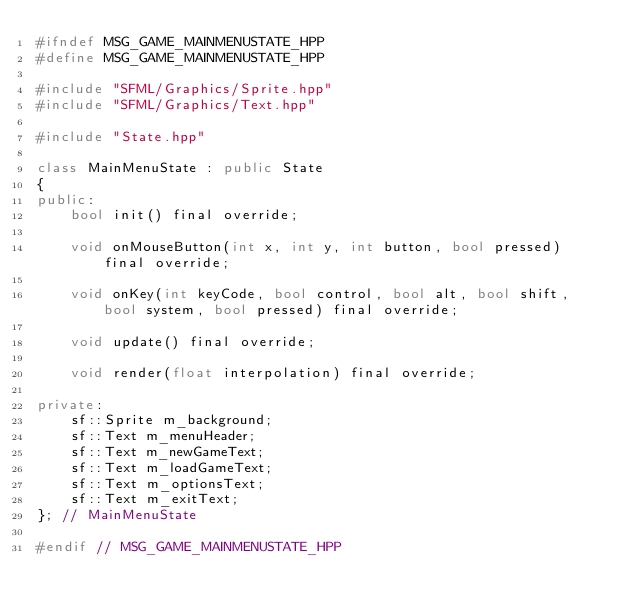Convert code to text. <code><loc_0><loc_0><loc_500><loc_500><_C++_>#ifndef MSG_GAME_MAINMENUSTATE_HPP
#define MSG_GAME_MAINMENUSTATE_HPP

#include "SFML/Graphics/Sprite.hpp"
#include "SFML/Graphics/Text.hpp"

#include "State.hpp"

class MainMenuState : public State
{
public:
    bool init() final override;

    void onMouseButton(int x, int y, int button, bool pressed) final override;

    void onKey(int keyCode, bool control, bool alt, bool shift, bool system, bool pressed) final override;

    void update() final override;

    void render(float interpolation) final override;

private:
    sf::Sprite m_background;
    sf::Text m_menuHeader;
    sf::Text m_newGameText;
    sf::Text m_loadGameText;
    sf::Text m_optionsText;
    sf::Text m_exitText;
}; // MainMenuState

#endif // MSG_GAME_MAINMENUSTATE_HPP
</code> 